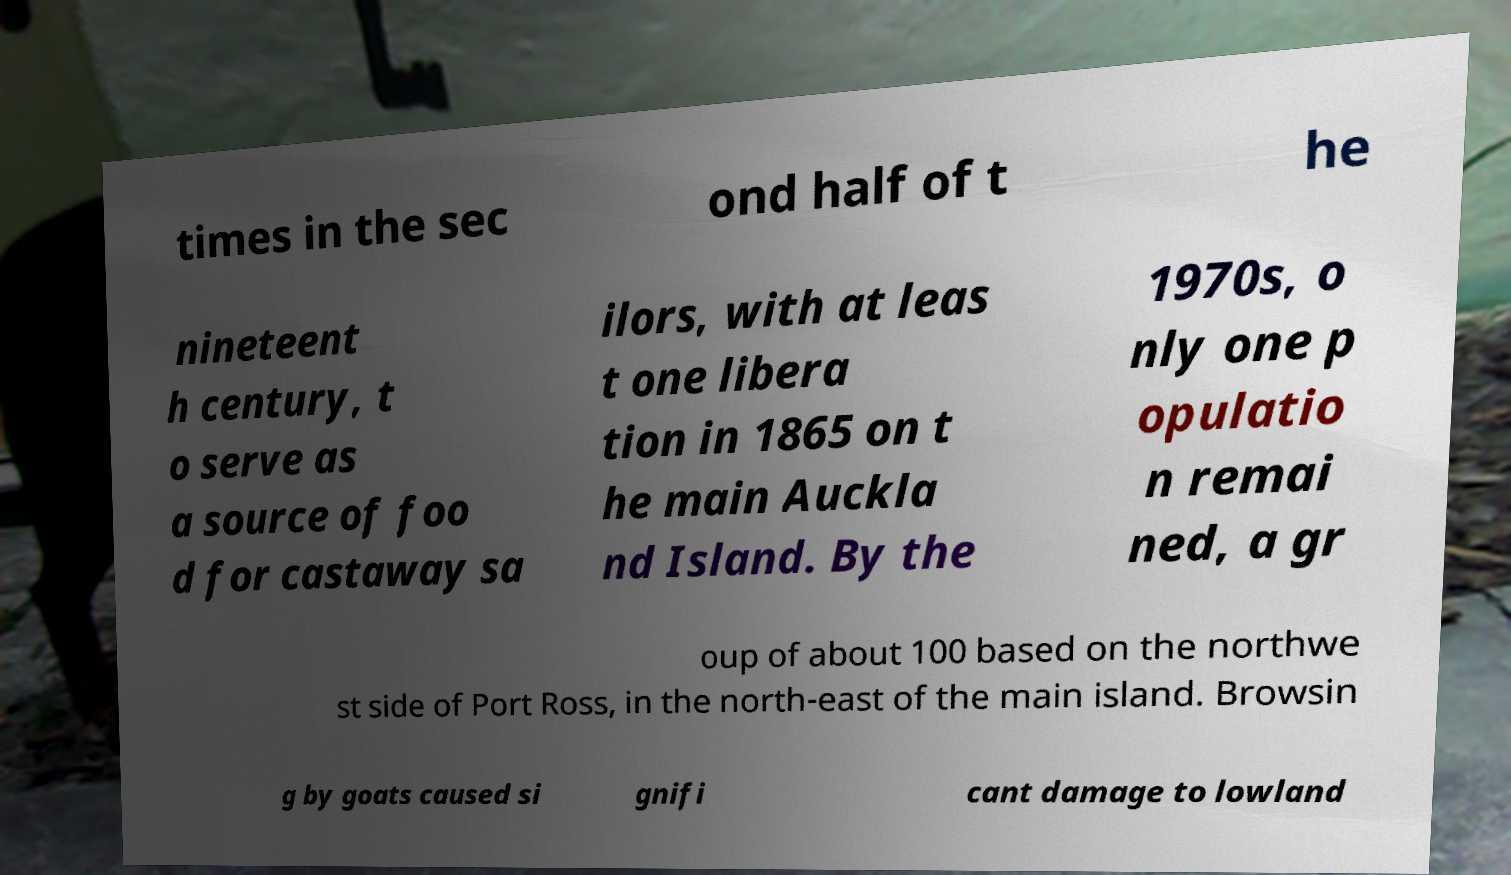Please identify and transcribe the text found in this image. times in the sec ond half of t he nineteent h century, t o serve as a source of foo d for castaway sa ilors, with at leas t one libera tion in 1865 on t he main Auckla nd Island. By the 1970s, o nly one p opulatio n remai ned, a gr oup of about 100 based on the northwe st side of Port Ross, in the north-east of the main island. Browsin g by goats caused si gnifi cant damage to lowland 